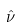<formula> <loc_0><loc_0><loc_500><loc_500>\hat { \nu }</formula> 